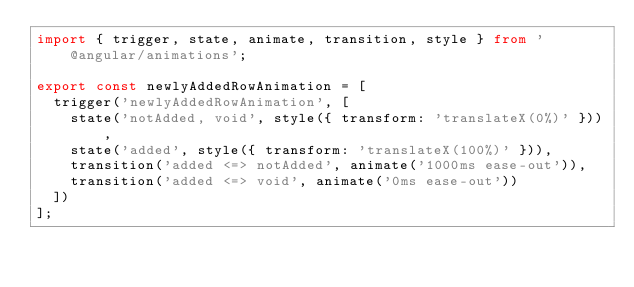Convert code to text. <code><loc_0><loc_0><loc_500><loc_500><_TypeScript_>import { trigger, state, animate, transition, style } from '@angular/animations';

export const newlyAddedRowAnimation = [
  trigger('newlyAddedRowAnimation', [
    state('notAdded, void', style({ transform: 'translateX(0%)' })),
    state('added', style({ transform: 'translateX(100%)' })),
    transition('added <=> notAdded', animate('1000ms ease-out')),
    transition('added <=> void', animate('0ms ease-out'))
  ])
];
</code> 